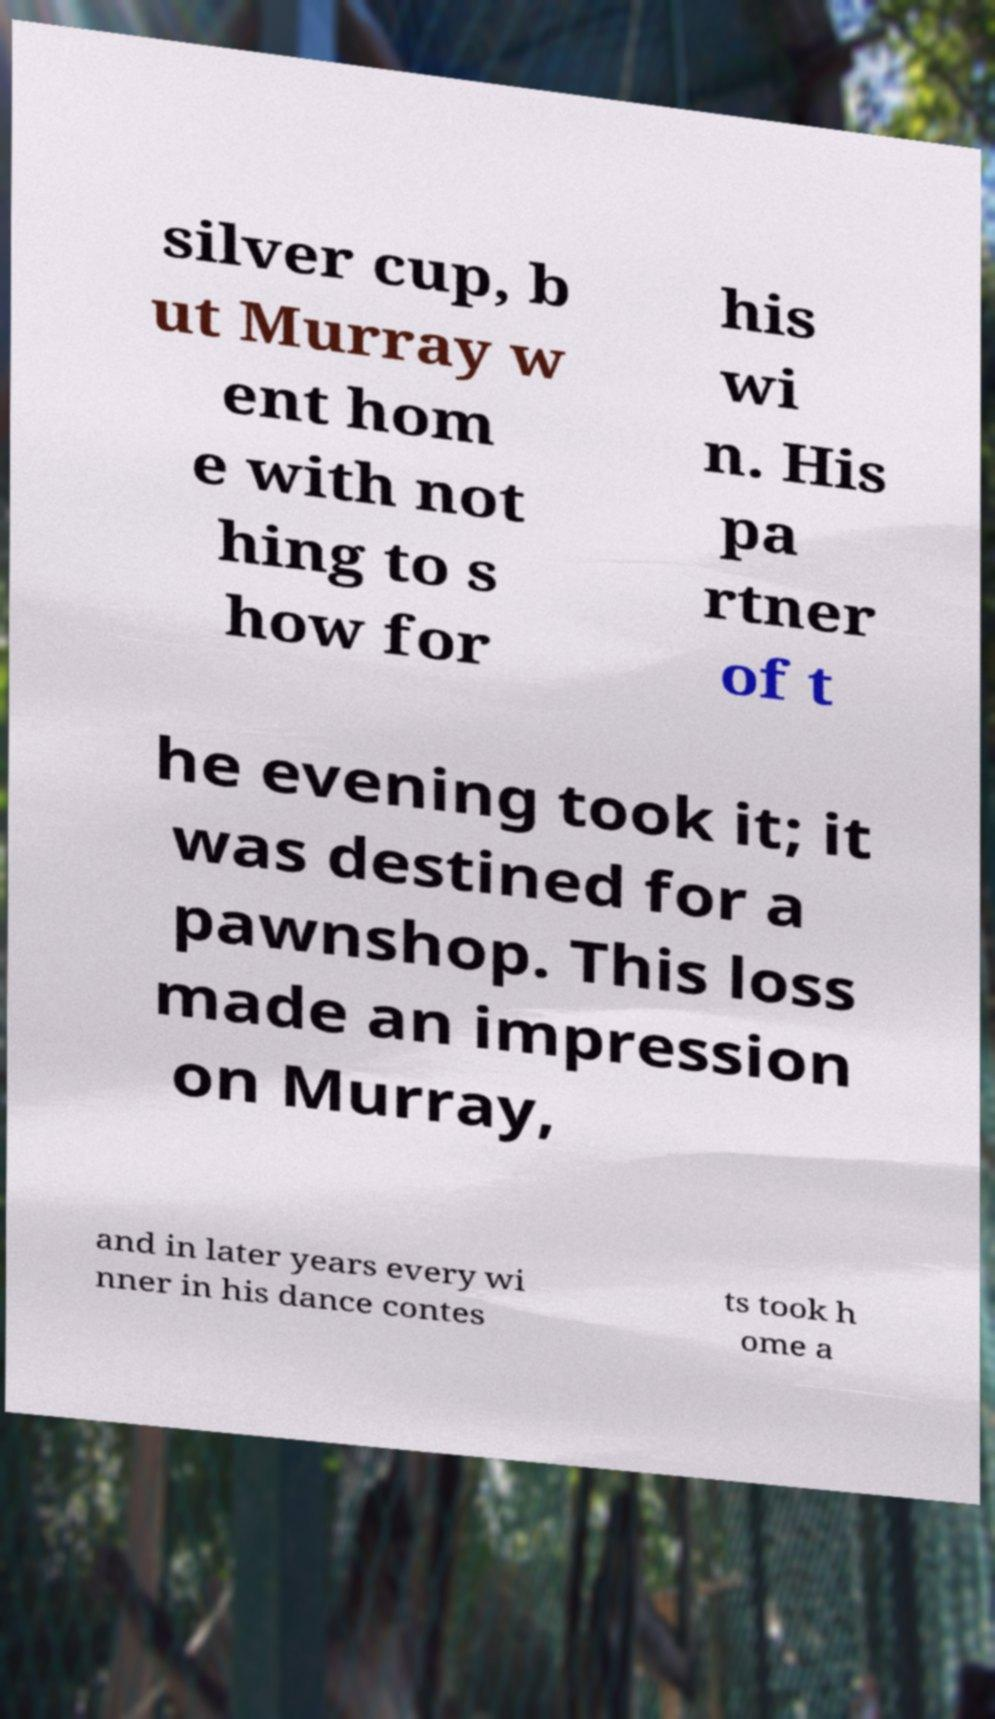For documentation purposes, I need the text within this image transcribed. Could you provide that? silver cup, b ut Murray w ent hom e with not hing to s how for his wi n. His pa rtner of t he evening took it; it was destined for a pawnshop. This loss made an impression on Murray, and in later years every wi nner in his dance contes ts took h ome a 